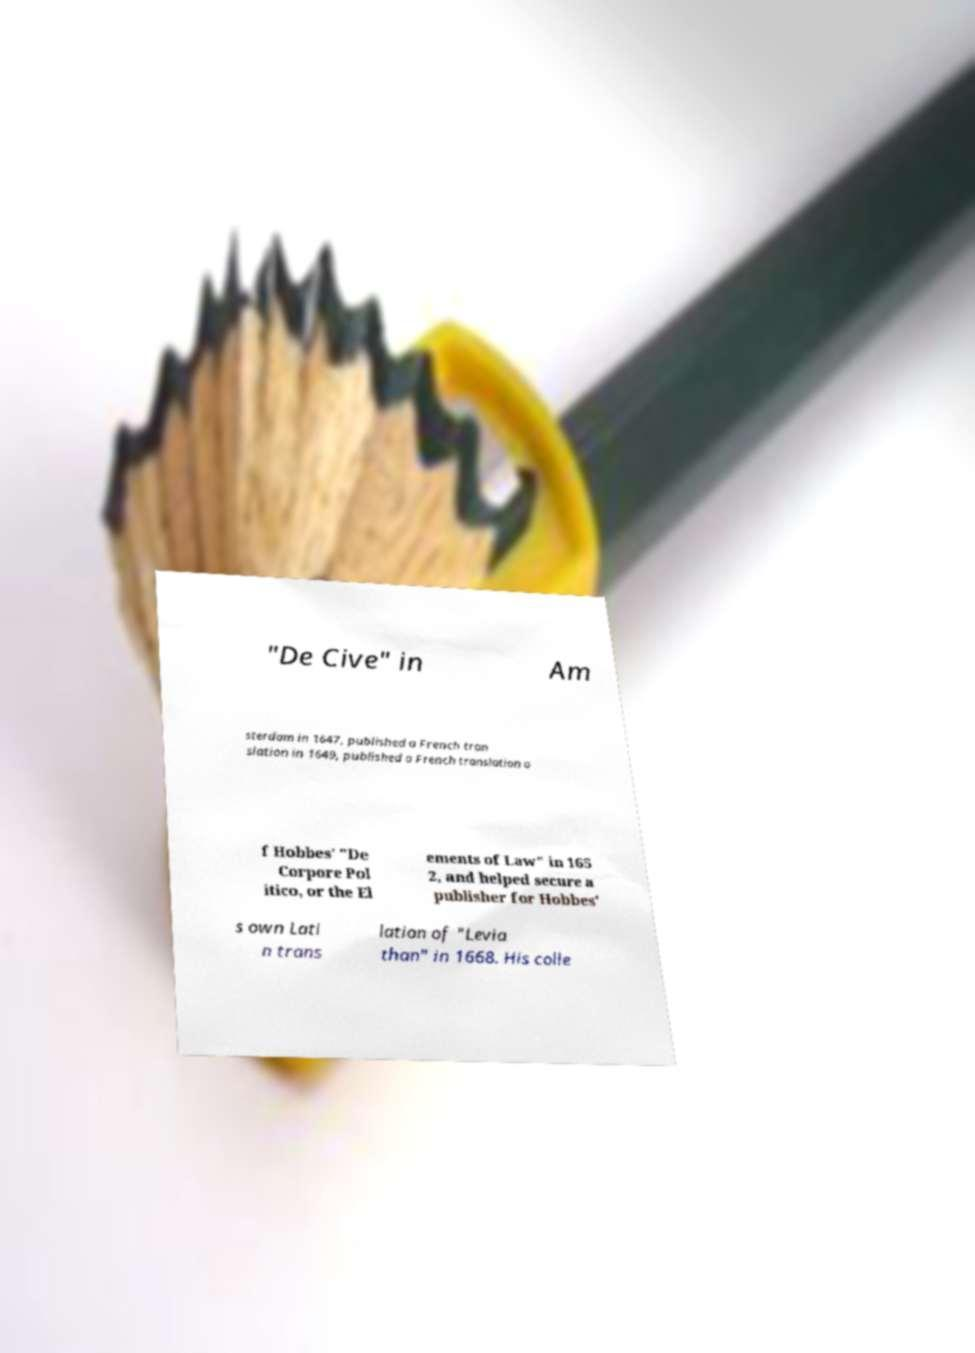Please identify and transcribe the text found in this image. "De Cive" in Am sterdam in 1647, published a French tran slation in 1649, published a French translation o f Hobbes' "De Corpore Pol itico, or the El ements of Law" in 165 2, and helped secure a publisher for Hobbes' s own Lati n trans lation of "Levia than" in 1668. His colle 